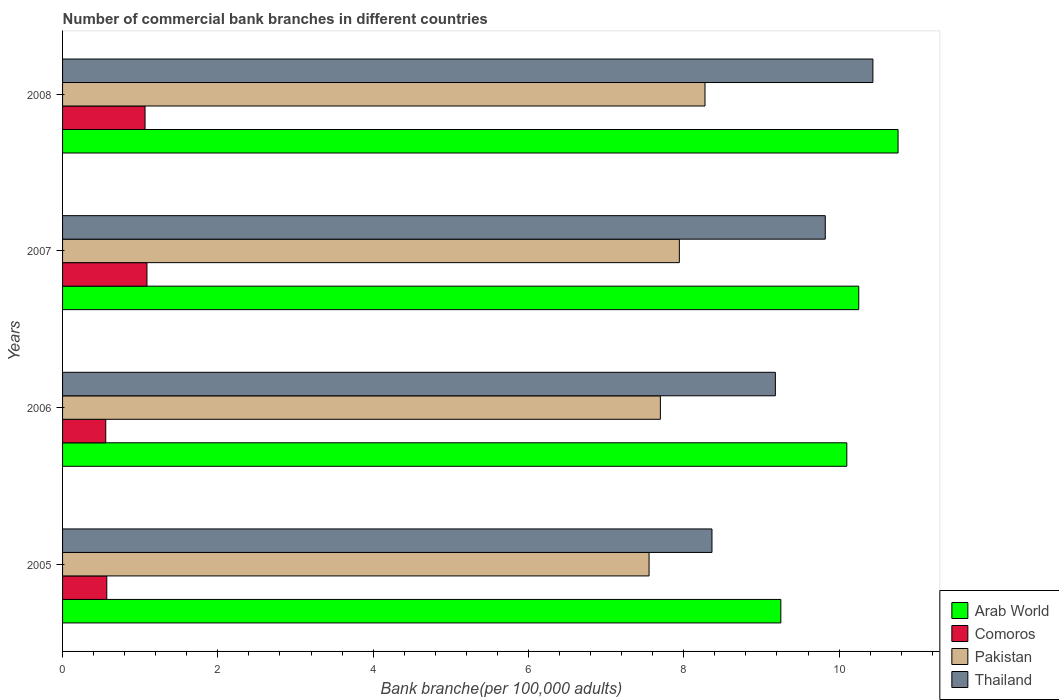How many different coloured bars are there?
Your response must be concise. 4. How many groups of bars are there?
Provide a short and direct response. 4. Are the number of bars per tick equal to the number of legend labels?
Your response must be concise. Yes. How many bars are there on the 2nd tick from the top?
Provide a succinct answer. 4. How many bars are there on the 1st tick from the bottom?
Give a very brief answer. 4. What is the number of commercial bank branches in Comoros in 2005?
Make the answer very short. 0.57. Across all years, what is the maximum number of commercial bank branches in Arab World?
Your response must be concise. 10.76. Across all years, what is the minimum number of commercial bank branches in Comoros?
Your answer should be very brief. 0.56. In which year was the number of commercial bank branches in Thailand minimum?
Provide a succinct answer. 2005. What is the total number of commercial bank branches in Comoros in the graph?
Offer a terse response. 3.27. What is the difference between the number of commercial bank branches in Comoros in 2005 and that in 2007?
Keep it short and to the point. -0.52. What is the difference between the number of commercial bank branches in Comoros in 2006 and the number of commercial bank branches in Pakistan in 2005?
Your answer should be compact. -7. What is the average number of commercial bank branches in Pakistan per year?
Offer a terse response. 7.87. In the year 2005, what is the difference between the number of commercial bank branches in Pakistan and number of commercial bank branches in Comoros?
Your response must be concise. 6.98. What is the ratio of the number of commercial bank branches in Arab World in 2007 to that in 2008?
Offer a very short reply. 0.95. Is the number of commercial bank branches in Thailand in 2005 less than that in 2007?
Provide a succinct answer. Yes. What is the difference between the highest and the second highest number of commercial bank branches in Thailand?
Make the answer very short. 0.61. What is the difference between the highest and the lowest number of commercial bank branches in Pakistan?
Provide a succinct answer. 0.72. In how many years, is the number of commercial bank branches in Arab World greater than the average number of commercial bank branches in Arab World taken over all years?
Make the answer very short. 3. Is it the case that in every year, the sum of the number of commercial bank branches in Comoros and number of commercial bank branches in Arab World is greater than the sum of number of commercial bank branches in Thailand and number of commercial bank branches in Pakistan?
Provide a short and direct response. Yes. What does the 4th bar from the top in 2006 represents?
Provide a succinct answer. Arab World. How many bars are there?
Keep it short and to the point. 16. Are all the bars in the graph horizontal?
Ensure brevity in your answer.  Yes. How many legend labels are there?
Ensure brevity in your answer.  4. How are the legend labels stacked?
Offer a very short reply. Vertical. What is the title of the graph?
Offer a terse response. Number of commercial bank branches in different countries. Does "Kyrgyz Republic" appear as one of the legend labels in the graph?
Provide a short and direct response. No. What is the label or title of the X-axis?
Give a very brief answer. Bank branche(per 100,0 adults). What is the Bank branche(per 100,000 adults) in Arab World in 2005?
Provide a succinct answer. 9.25. What is the Bank branche(per 100,000 adults) of Comoros in 2005?
Make the answer very short. 0.57. What is the Bank branche(per 100,000 adults) in Pakistan in 2005?
Make the answer very short. 7.55. What is the Bank branche(per 100,000 adults) of Thailand in 2005?
Provide a short and direct response. 8.36. What is the Bank branche(per 100,000 adults) of Arab World in 2006?
Your answer should be compact. 10.1. What is the Bank branche(per 100,000 adults) in Comoros in 2006?
Give a very brief answer. 0.56. What is the Bank branche(per 100,000 adults) in Pakistan in 2006?
Offer a very short reply. 7.7. What is the Bank branche(per 100,000 adults) in Thailand in 2006?
Provide a succinct answer. 9.18. What is the Bank branche(per 100,000 adults) in Arab World in 2007?
Your answer should be compact. 10.25. What is the Bank branche(per 100,000 adults) of Comoros in 2007?
Offer a terse response. 1.09. What is the Bank branche(per 100,000 adults) in Pakistan in 2007?
Your answer should be compact. 7.94. What is the Bank branche(per 100,000 adults) in Thailand in 2007?
Make the answer very short. 9.82. What is the Bank branche(per 100,000 adults) in Arab World in 2008?
Offer a terse response. 10.76. What is the Bank branche(per 100,000 adults) in Comoros in 2008?
Ensure brevity in your answer.  1.06. What is the Bank branche(per 100,000 adults) in Pakistan in 2008?
Offer a very short reply. 8.27. What is the Bank branche(per 100,000 adults) in Thailand in 2008?
Keep it short and to the point. 10.44. Across all years, what is the maximum Bank branche(per 100,000 adults) in Arab World?
Give a very brief answer. 10.76. Across all years, what is the maximum Bank branche(per 100,000 adults) in Comoros?
Provide a succinct answer. 1.09. Across all years, what is the maximum Bank branche(per 100,000 adults) in Pakistan?
Offer a terse response. 8.27. Across all years, what is the maximum Bank branche(per 100,000 adults) of Thailand?
Give a very brief answer. 10.44. Across all years, what is the minimum Bank branche(per 100,000 adults) of Arab World?
Your answer should be very brief. 9.25. Across all years, what is the minimum Bank branche(per 100,000 adults) of Comoros?
Ensure brevity in your answer.  0.56. Across all years, what is the minimum Bank branche(per 100,000 adults) in Pakistan?
Offer a terse response. 7.55. Across all years, what is the minimum Bank branche(per 100,000 adults) of Thailand?
Make the answer very short. 8.36. What is the total Bank branche(per 100,000 adults) in Arab World in the graph?
Provide a short and direct response. 40.36. What is the total Bank branche(per 100,000 adults) in Comoros in the graph?
Provide a short and direct response. 3.27. What is the total Bank branche(per 100,000 adults) of Pakistan in the graph?
Offer a terse response. 31.47. What is the total Bank branche(per 100,000 adults) of Thailand in the graph?
Provide a succinct answer. 37.8. What is the difference between the Bank branche(per 100,000 adults) of Arab World in 2005 and that in 2006?
Keep it short and to the point. -0.85. What is the difference between the Bank branche(per 100,000 adults) in Comoros in 2005 and that in 2006?
Make the answer very short. 0.01. What is the difference between the Bank branche(per 100,000 adults) in Pakistan in 2005 and that in 2006?
Provide a succinct answer. -0.15. What is the difference between the Bank branche(per 100,000 adults) in Thailand in 2005 and that in 2006?
Ensure brevity in your answer.  -0.82. What is the difference between the Bank branche(per 100,000 adults) in Arab World in 2005 and that in 2007?
Your answer should be compact. -1. What is the difference between the Bank branche(per 100,000 adults) in Comoros in 2005 and that in 2007?
Offer a terse response. -0.52. What is the difference between the Bank branche(per 100,000 adults) in Pakistan in 2005 and that in 2007?
Your answer should be very brief. -0.39. What is the difference between the Bank branche(per 100,000 adults) in Thailand in 2005 and that in 2007?
Ensure brevity in your answer.  -1.46. What is the difference between the Bank branche(per 100,000 adults) in Arab World in 2005 and that in 2008?
Your response must be concise. -1.51. What is the difference between the Bank branche(per 100,000 adults) of Comoros in 2005 and that in 2008?
Make the answer very short. -0.49. What is the difference between the Bank branche(per 100,000 adults) of Pakistan in 2005 and that in 2008?
Offer a terse response. -0.72. What is the difference between the Bank branche(per 100,000 adults) of Thailand in 2005 and that in 2008?
Provide a short and direct response. -2.07. What is the difference between the Bank branche(per 100,000 adults) of Arab World in 2006 and that in 2007?
Your response must be concise. -0.15. What is the difference between the Bank branche(per 100,000 adults) in Comoros in 2006 and that in 2007?
Give a very brief answer. -0.53. What is the difference between the Bank branche(per 100,000 adults) in Pakistan in 2006 and that in 2007?
Give a very brief answer. -0.24. What is the difference between the Bank branche(per 100,000 adults) of Thailand in 2006 and that in 2007?
Make the answer very short. -0.64. What is the difference between the Bank branche(per 100,000 adults) of Arab World in 2006 and that in 2008?
Keep it short and to the point. -0.66. What is the difference between the Bank branche(per 100,000 adults) of Comoros in 2006 and that in 2008?
Your response must be concise. -0.51. What is the difference between the Bank branche(per 100,000 adults) of Pakistan in 2006 and that in 2008?
Offer a terse response. -0.57. What is the difference between the Bank branche(per 100,000 adults) of Thailand in 2006 and that in 2008?
Your response must be concise. -1.26. What is the difference between the Bank branche(per 100,000 adults) of Arab World in 2007 and that in 2008?
Give a very brief answer. -0.51. What is the difference between the Bank branche(per 100,000 adults) of Comoros in 2007 and that in 2008?
Your answer should be compact. 0.02. What is the difference between the Bank branche(per 100,000 adults) in Pakistan in 2007 and that in 2008?
Your response must be concise. -0.33. What is the difference between the Bank branche(per 100,000 adults) in Thailand in 2007 and that in 2008?
Give a very brief answer. -0.61. What is the difference between the Bank branche(per 100,000 adults) of Arab World in 2005 and the Bank branche(per 100,000 adults) of Comoros in 2006?
Make the answer very short. 8.69. What is the difference between the Bank branche(per 100,000 adults) in Arab World in 2005 and the Bank branche(per 100,000 adults) in Pakistan in 2006?
Keep it short and to the point. 1.55. What is the difference between the Bank branche(per 100,000 adults) in Arab World in 2005 and the Bank branche(per 100,000 adults) in Thailand in 2006?
Your answer should be compact. 0.07. What is the difference between the Bank branche(per 100,000 adults) in Comoros in 2005 and the Bank branche(per 100,000 adults) in Pakistan in 2006?
Offer a terse response. -7.13. What is the difference between the Bank branche(per 100,000 adults) of Comoros in 2005 and the Bank branche(per 100,000 adults) of Thailand in 2006?
Your response must be concise. -8.61. What is the difference between the Bank branche(per 100,000 adults) of Pakistan in 2005 and the Bank branche(per 100,000 adults) of Thailand in 2006?
Your answer should be very brief. -1.63. What is the difference between the Bank branche(per 100,000 adults) of Arab World in 2005 and the Bank branche(per 100,000 adults) of Comoros in 2007?
Your answer should be compact. 8.16. What is the difference between the Bank branche(per 100,000 adults) of Arab World in 2005 and the Bank branche(per 100,000 adults) of Pakistan in 2007?
Provide a short and direct response. 1.31. What is the difference between the Bank branche(per 100,000 adults) of Arab World in 2005 and the Bank branche(per 100,000 adults) of Thailand in 2007?
Provide a short and direct response. -0.57. What is the difference between the Bank branche(per 100,000 adults) of Comoros in 2005 and the Bank branche(per 100,000 adults) of Pakistan in 2007?
Keep it short and to the point. -7.37. What is the difference between the Bank branche(per 100,000 adults) of Comoros in 2005 and the Bank branche(per 100,000 adults) of Thailand in 2007?
Your answer should be compact. -9.25. What is the difference between the Bank branche(per 100,000 adults) in Pakistan in 2005 and the Bank branche(per 100,000 adults) in Thailand in 2007?
Your response must be concise. -2.27. What is the difference between the Bank branche(per 100,000 adults) in Arab World in 2005 and the Bank branche(per 100,000 adults) in Comoros in 2008?
Your answer should be very brief. 8.19. What is the difference between the Bank branche(per 100,000 adults) in Arab World in 2005 and the Bank branche(per 100,000 adults) in Pakistan in 2008?
Provide a succinct answer. 0.98. What is the difference between the Bank branche(per 100,000 adults) in Arab World in 2005 and the Bank branche(per 100,000 adults) in Thailand in 2008?
Provide a short and direct response. -1.19. What is the difference between the Bank branche(per 100,000 adults) in Comoros in 2005 and the Bank branche(per 100,000 adults) in Pakistan in 2008?
Keep it short and to the point. -7.7. What is the difference between the Bank branche(per 100,000 adults) of Comoros in 2005 and the Bank branche(per 100,000 adults) of Thailand in 2008?
Your answer should be compact. -9.87. What is the difference between the Bank branche(per 100,000 adults) in Pakistan in 2005 and the Bank branche(per 100,000 adults) in Thailand in 2008?
Your response must be concise. -2.88. What is the difference between the Bank branche(per 100,000 adults) of Arab World in 2006 and the Bank branche(per 100,000 adults) of Comoros in 2007?
Provide a succinct answer. 9.01. What is the difference between the Bank branche(per 100,000 adults) of Arab World in 2006 and the Bank branche(per 100,000 adults) of Pakistan in 2007?
Your answer should be very brief. 2.16. What is the difference between the Bank branche(per 100,000 adults) of Arab World in 2006 and the Bank branche(per 100,000 adults) of Thailand in 2007?
Make the answer very short. 0.28. What is the difference between the Bank branche(per 100,000 adults) of Comoros in 2006 and the Bank branche(per 100,000 adults) of Pakistan in 2007?
Give a very brief answer. -7.39. What is the difference between the Bank branche(per 100,000 adults) in Comoros in 2006 and the Bank branche(per 100,000 adults) in Thailand in 2007?
Provide a short and direct response. -9.27. What is the difference between the Bank branche(per 100,000 adults) of Pakistan in 2006 and the Bank branche(per 100,000 adults) of Thailand in 2007?
Your answer should be very brief. -2.12. What is the difference between the Bank branche(per 100,000 adults) in Arab World in 2006 and the Bank branche(per 100,000 adults) in Comoros in 2008?
Offer a very short reply. 9.04. What is the difference between the Bank branche(per 100,000 adults) in Arab World in 2006 and the Bank branche(per 100,000 adults) in Pakistan in 2008?
Provide a succinct answer. 1.83. What is the difference between the Bank branche(per 100,000 adults) in Arab World in 2006 and the Bank branche(per 100,000 adults) in Thailand in 2008?
Keep it short and to the point. -0.34. What is the difference between the Bank branche(per 100,000 adults) in Comoros in 2006 and the Bank branche(per 100,000 adults) in Pakistan in 2008?
Your answer should be compact. -7.72. What is the difference between the Bank branche(per 100,000 adults) in Comoros in 2006 and the Bank branche(per 100,000 adults) in Thailand in 2008?
Keep it short and to the point. -9.88. What is the difference between the Bank branche(per 100,000 adults) of Pakistan in 2006 and the Bank branche(per 100,000 adults) of Thailand in 2008?
Ensure brevity in your answer.  -2.74. What is the difference between the Bank branche(per 100,000 adults) of Arab World in 2007 and the Bank branche(per 100,000 adults) of Comoros in 2008?
Make the answer very short. 9.19. What is the difference between the Bank branche(per 100,000 adults) of Arab World in 2007 and the Bank branche(per 100,000 adults) of Pakistan in 2008?
Your answer should be compact. 1.98. What is the difference between the Bank branche(per 100,000 adults) of Arab World in 2007 and the Bank branche(per 100,000 adults) of Thailand in 2008?
Offer a very short reply. -0.18. What is the difference between the Bank branche(per 100,000 adults) in Comoros in 2007 and the Bank branche(per 100,000 adults) in Pakistan in 2008?
Provide a succinct answer. -7.19. What is the difference between the Bank branche(per 100,000 adults) of Comoros in 2007 and the Bank branche(per 100,000 adults) of Thailand in 2008?
Your answer should be very brief. -9.35. What is the difference between the Bank branche(per 100,000 adults) of Pakistan in 2007 and the Bank branche(per 100,000 adults) of Thailand in 2008?
Your response must be concise. -2.49. What is the average Bank branche(per 100,000 adults) of Arab World per year?
Ensure brevity in your answer.  10.09. What is the average Bank branche(per 100,000 adults) in Comoros per year?
Your answer should be very brief. 0.82. What is the average Bank branche(per 100,000 adults) in Pakistan per year?
Your answer should be very brief. 7.87. What is the average Bank branche(per 100,000 adults) in Thailand per year?
Provide a short and direct response. 9.45. In the year 2005, what is the difference between the Bank branche(per 100,000 adults) in Arab World and Bank branche(per 100,000 adults) in Comoros?
Make the answer very short. 8.68. In the year 2005, what is the difference between the Bank branche(per 100,000 adults) in Arab World and Bank branche(per 100,000 adults) in Pakistan?
Offer a very short reply. 1.7. In the year 2005, what is the difference between the Bank branche(per 100,000 adults) of Arab World and Bank branche(per 100,000 adults) of Thailand?
Give a very brief answer. 0.89. In the year 2005, what is the difference between the Bank branche(per 100,000 adults) of Comoros and Bank branche(per 100,000 adults) of Pakistan?
Offer a very short reply. -6.98. In the year 2005, what is the difference between the Bank branche(per 100,000 adults) in Comoros and Bank branche(per 100,000 adults) in Thailand?
Offer a terse response. -7.79. In the year 2005, what is the difference between the Bank branche(per 100,000 adults) of Pakistan and Bank branche(per 100,000 adults) of Thailand?
Keep it short and to the point. -0.81. In the year 2006, what is the difference between the Bank branche(per 100,000 adults) of Arab World and Bank branche(per 100,000 adults) of Comoros?
Offer a terse response. 9.54. In the year 2006, what is the difference between the Bank branche(per 100,000 adults) of Arab World and Bank branche(per 100,000 adults) of Pakistan?
Make the answer very short. 2.4. In the year 2006, what is the difference between the Bank branche(per 100,000 adults) in Arab World and Bank branche(per 100,000 adults) in Thailand?
Your response must be concise. 0.92. In the year 2006, what is the difference between the Bank branche(per 100,000 adults) in Comoros and Bank branche(per 100,000 adults) in Pakistan?
Provide a succinct answer. -7.14. In the year 2006, what is the difference between the Bank branche(per 100,000 adults) in Comoros and Bank branche(per 100,000 adults) in Thailand?
Make the answer very short. -8.62. In the year 2006, what is the difference between the Bank branche(per 100,000 adults) in Pakistan and Bank branche(per 100,000 adults) in Thailand?
Keep it short and to the point. -1.48. In the year 2007, what is the difference between the Bank branche(per 100,000 adults) in Arab World and Bank branche(per 100,000 adults) in Comoros?
Offer a terse response. 9.17. In the year 2007, what is the difference between the Bank branche(per 100,000 adults) of Arab World and Bank branche(per 100,000 adults) of Pakistan?
Provide a short and direct response. 2.31. In the year 2007, what is the difference between the Bank branche(per 100,000 adults) of Arab World and Bank branche(per 100,000 adults) of Thailand?
Offer a terse response. 0.43. In the year 2007, what is the difference between the Bank branche(per 100,000 adults) of Comoros and Bank branche(per 100,000 adults) of Pakistan?
Ensure brevity in your answer.  -6.86. In the year 2007, what is the difference between the Bank branche(per 100,000 adults) of Comoros and Bank branche(per 100,000 adults) of Thailand?
Ensure brevity in your answer.  -8.74. In the year 2007, what is the difference between the Bank branche(per 100,000 adults) in Pakistan and Bank branche(per 100,000 adults) in Thailand?
Ensure brevity in your answer.  -1.88. In the year 2008, what is the difference between the Bank branche(per 100,000 adults) of Arab World and Bank branche(per 100,000 adults) of Comoros?
Your answer should be very brief. 9.7. In the year 2008, what is the difference between the Bank branche(per 100,000 adults) of Arab World and Bank branche(per 100,000 adults) of Pakistan?
Your answer should be very brief. 2.49. In the year 2008, what is the difference between the Bank branche(per 100,000 adults) in Arab World and Bank branche(per 100,000 adults) in Thailand?
Make the answer very short. 0.32. In the year 2008, what is the difference between the Bank branche(per 100,000 adults) of Comoros and Bank branche(per 100,000 adults) of Pakistan?
Your response must be concise. -7.21. In the year 2008, what is the difference between the Bank branche(per 100,000 adults) of Comoros and Bank branche(per 100,000 adults) of Thailand?
Keep it short and to the point. -9.37. In the year 2008, what is the difference between the Bank branche(per 100,000 adults) in Pakistan and Bank branche(per 100,000 adults) in Thailand?
Offer a very short reply. -2.16. What is the ratio of the Bank branche(per 100,000 adults) in Arab World in 2005 to that in 2006?
Make the answer very short. 0.92. What is the ratio of the Bank branche(per 100,000 adults) in Comoros in 2005 to that in 2006?
Make the answer very short. 1.02. What is the ratio of the Bank branche(per 100,000 adults) in Pakistan in 2005 to that in 2006?
Your answer should be very brief. 0.98. What is the ratio of the Bank branche(per 100,000 adults) in Thailand in 2005 to that in 2006?
Offer a very short reply. 0.91. What is the ratio of the Bank branche(per 100,000 adults) of Arab World in 2005 to that in 2007?
Make the answer very short. 0.9. What is the ratio of the Bank branche(per 100,000 adults) of Comoros in 2005 to that in 2007?
Ensure brevity in your answer.  0.52. What is the ratio of the Bank branche(per 100,000 adults) in Pakistan in 2005 to that in 2007?
Give a very brief answer. 0.95. What is the ratio of the Bank branche(per 100,000 adults) of Thailand in 2005 to that in 2007?
Your answer should be compact. 0.85. What is the ratio of the Bank branche(per 100,000 adults) in Arab World in 2005 to that in 2008?
Make the answer very short. 0.86. What is the ratio of the Bank branche(per 100,000 adults) of Comoros in 2005 to that in 2008?
Offer a very short reply. 0.54. What is the ratio of the Bank branche(per 100,000 adults) of Pakistan in 2005 to that in 2008?
Provide a succinct answer. 0.91. What is the ratio of the Bank branche(per 100,000 adults) of Thailand in 2005 to that in 2008?
Your response must be concise. 0.8. What is the ratio of the Bank branche(per 100,000 adults) of Arab World in 2006 to that in 2007?
Ensure brevity in your answer.  0.98. What is the ratio of the Bank branche(per 100,000 adults) of Comoros in 2006 to that in 2007?
Your answer should be compact. 0.51. What is the ratio of the Bank branche(per 100,000 adults) in Pakistan in 2006 to that in 2007?
Your answer should be very brief. 0.97. What is the ratio of the Bank branche(per 100,000 adults) in Thailand in 2006 to that in 2007?
Provide a succinct answer. 0.93. What is the ratio of the Bank branche(per 100,000 adults) of Arab World in 2006 to that in 2008?
Your answer should be very brief. 0.94. What is the ratio of the Bank branche(per 100,000 adults) of Comoros in 2006 to that in 2008?
Your response must be concise. 0.52. What is the ratio of the Bank branche(per 100,000 adults) in Pakistan in 2006 to that in 2008?
Your answer should be very brief. 0.93. What is the ratio of the Bank branche(per 100,000 adults) in Thailand in 2006 to that in 2008?
Ensure brevity in your answer.  0.88. What is the ratio of the Bank branche(per 100,000 adults) of Arab World in 2007 to that in 2008?
Your response must be concise. 0.95. What is the ratio of the Bank branche(per 100,000 adults) in Comoros in 2007 to that in 2008?
Ensure brevity in your answer.  1.02. What is the ratio of the Bank branche(per 100,000 adults) of Pakistan in 2007 to that in 2008?
Give a very brief answer. 0.96. What is the ratio of the Bank branche(per 100,000 adults) of Thailand in 2007 to that in 2008?
Offer a very short reply. 0.94. What is the difference between the highest and the second highest Bank branche(per 100,000 adults) of Arab World?
Make the answer very short. 0.51. What is the difference between the highest and the second highest Bank branche(per 100,000 adults) of Comoros?
Your answer should be very brief. 0.02. What is the difference between the highest and the second highest Bank branche(per 100,000 adults) in Pakistan?
Your answer should be very brief. 0.33. What is the difference between the highest and the second highest Bank branche(per 100,000 adults) of Thailand?
Ensure brevity in your answer.  0.61. What is the difference between the highest and the lowest Bank branche(per 100,000 adults) in Arab World?
Ensure brevity in your answer.  1.51. What is the difference between the highest and the lowest Bank branche(per 100,000 adults) of Comoros?
Your response must be concise. 0.53. What is the difference between the highest and the lowest Bank branche(per 100,000 adults) in Pakistan?
Your response must be concise. 0.72. What is the difference between the highest and the lowest Bank branche(per 100,000 adults) in Thailand?
Keep it short and to the point. 2.07. 